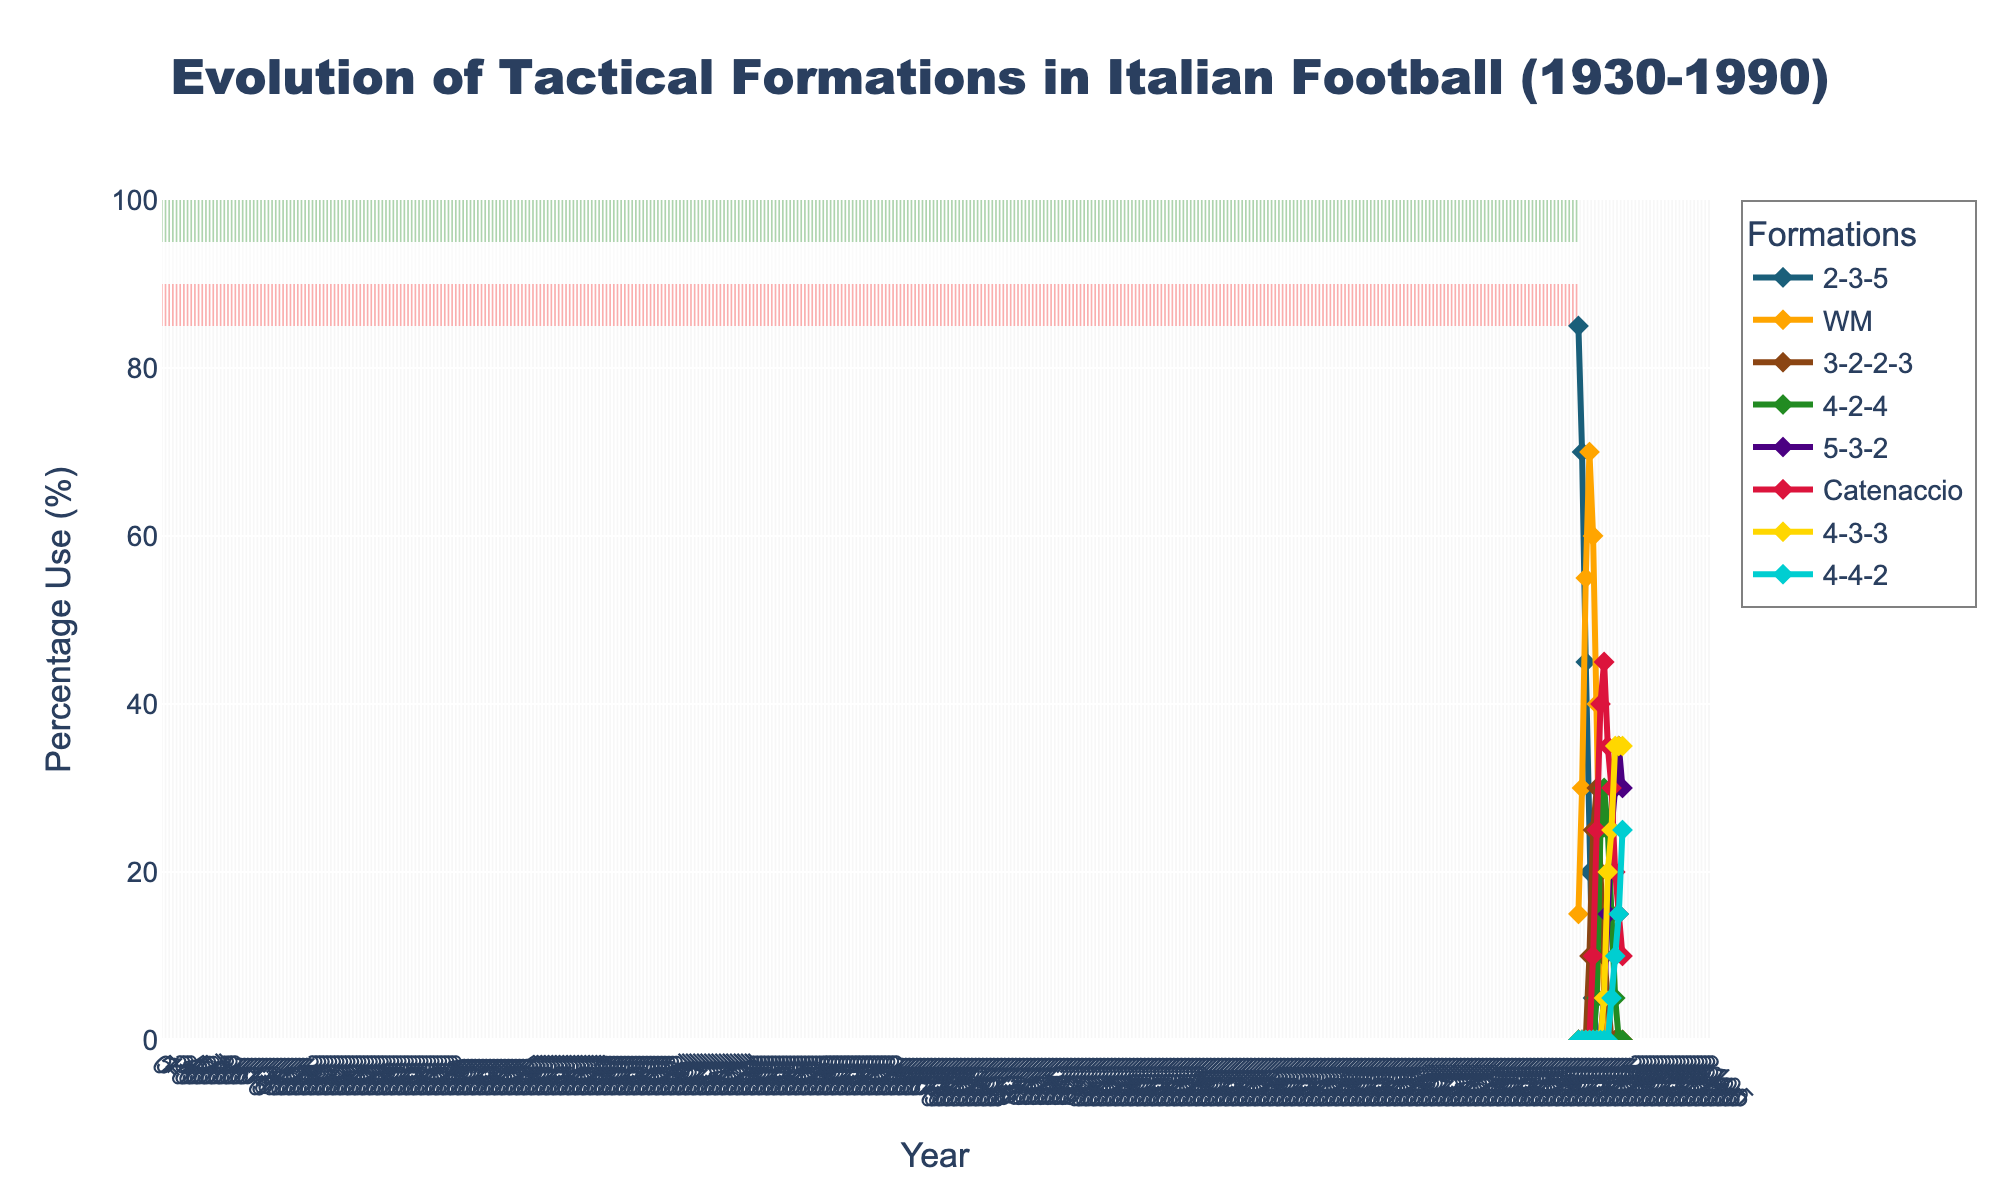What's the earliest year when the WM formation exceeded 50% of use? By examining the line for the WM formation, we see it cross the 50% mark around 1940.
Answer: 1940 Which formation had the highest usage percentage in 1930? In 1930, the 2-3-5 formation had the highest line on the chart, indicating the highest usage percentage.
Answer: 2-3-5 What was the percentage use of the 4-4-2 formation in 1990? By locating the year 1990 on the x-axis and following the line for the 4-4-2 formation, its value touches 25%.
Answer: 25% Between 1950 and 1960, did the usage of the Catenaccio formation increase or decrease? From 1950 to 1960, the Catenaccio formation line ascends, indicating an increase.
Answer: Increase In what year did the 4-3-3 formation and the 4-4-2 formation have equal usage percentages? The lines for the 4-3-3 and 4-4-2 formations intersect in 1985, indicating equal usage.
Answer: 1985 What is the sum of the use percentages of the 5-3-2 and the 4-2-4 formations in 1970? The 5-3-2 is at 15% and the 4-2-4 is at 25% in 1970; their sum is 15 + 25 = 40%.
Answer: 40% Which formation saw a noticeable rise in usage around 1965? The line for the 4-2-4 formation rises significantly around 1965, indicating an increase in usage.
Answer: 4-2-4 What was the trend for the usage of the WM formation from 1930 to 1955? Examining the WM line, it consistently rises from 1930 until peaking around 1945 and then falls until 1955.
Answer: Rise then fall How did the use of the 3-2-2-3 formation change between 1945 and 1955? The 3-2-2-3 formation increases from 10% in 1945 to 25% in 1950 and then slightly to 30% in 1955, showing a steady rise.
Answer: Steady rise 